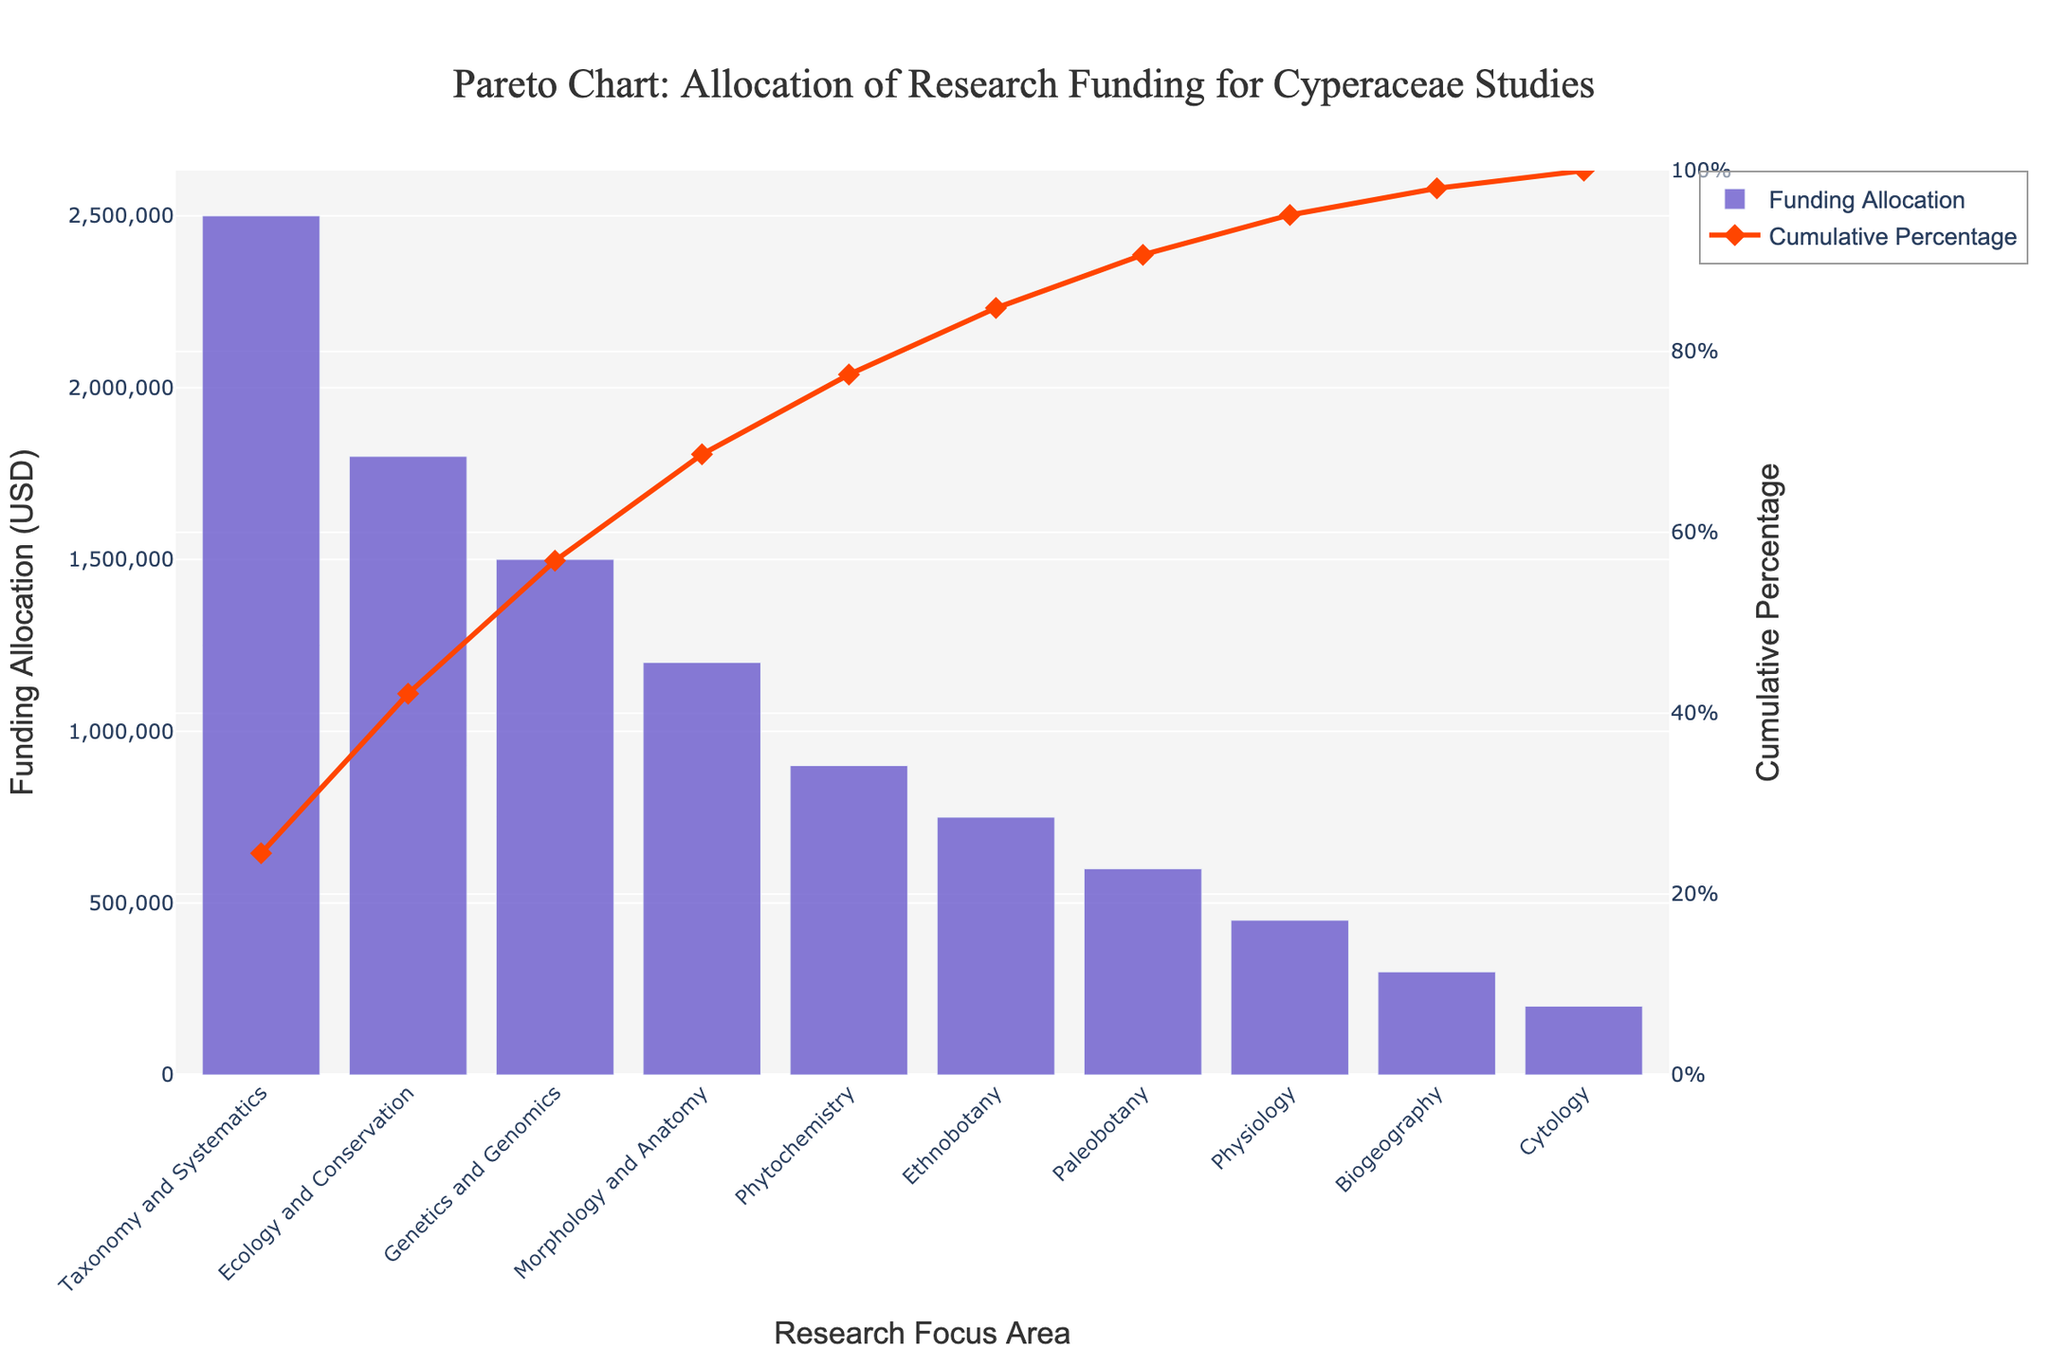What is the research focus area with the highest funding allocation? The bar chart shows that 'Taxonomy and Systematics' has the highest funding at $2,500,000.
Answer: Taxonomy and Systematics What is the cumulative percentage for 'Ecology and Conservation'? The line chart indicates that at 'Ecology and Conservation', the cumulative percentage reaches around 48.78%.
Answer: 48.78% How much more funding does 'Taxonomy and Systematics' receive compared to 'Genetics and Genomics'? 'Taxonomy and Systematics' receives $2,500,000 and 'Genetics and Genomics' receives $1,500,000. The difference is $2,500,000 - $1,500,000 = $1,000,000.
Answer: $1,000,000 Which research focus area achieves a cumulative percentage of around 76%? From the line chart, 'Morphology and Anatomy' achieves a cumulative percentage near 76%.
Answer: Morphology and Anatomy What is the funding allocation for 'Physiology'? The bar chart shows 'Physiology' has a funding allocation of $450,000.
Answer: $450,000 What is the total funding allocated to the top three research focus areas? The top three areas are 'Taxonomy and Systematics', 'Ecology and Conservation', and 'Genetics and Genomics', with $2,500,000 + $1,800,000 + $1,500,000 = $5,800,000 in total.
Answer: $5,800,000 Which research focus areas receive less than $1,000,000 in funding allocation? The bar chart indicates that 'Phytochemistry', 'Ethnobotany', 'Paleobotany', 'Physiology', 'Biogeography', and 'Cytology' each have less than $1,000,000 in funding.
Answer: Phytochemistry, Ethnobotany, Paleobotany, Physiology, Biogeography, Cytology How many research focus areas are there in total? There are 10 bar segments representing the different research focus areas.
Answer: 10 What is the cumulative percentage threshold achieved by the top four funded research focus areas? Adding the contributions of the top four areas, the cumulative percentage is about 48.78% (Ecology and Conservation) + 27.03% (Taxonomy and Systematics) + Genetics and Genomics 16.89 + 9.95 (Morphology and Anatomy) = 82.65%.
Answer: 82.65% 